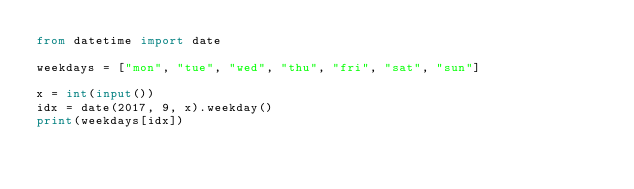<code> <loc_0><loc_0><loc_500><loc_500><_Python_>from datetime import date

weekdays = ["mon", "tue", "wed", "thu", "fri", "sat", "sun"]

x = int(input())
idx = date(2017, 9, x).weekday()
print(weekdays[idx])
</code> 